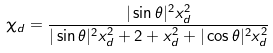Convert formula to latex. <formula><loc_0><loc_0><loc_500><loc_500>\chi _ { d } = \frac { | \sin \theta | ^ { 2 } x _ { d } ^ { 2 } } { | \sin \theta | ^ { 2 } x _ { d } ^ { 2 } + 2 + x _ { d } ^ { 2 } + | \cos \theta | ^ { 2 } x _ { d } ^ { 2 } }</formula> 